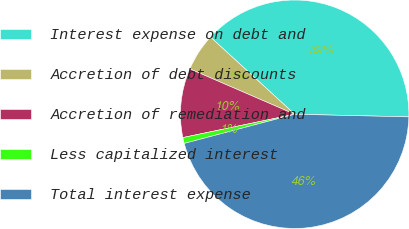Convert chart to OTSL. <chart><loc_0><loc_0><loc_500><loc_500><pie_chart><fcel>Interest expense on debt and<fcel>Accretion of debt discounts<fcel>Accretion of remediation and<fcel>Less capitalized interest<fcel>Total interest expense<nl><fcel>38.56%<fcel>5.31%<fcel>9.77%<fcel>0.84%<fcel>45.52%<nl></chart> 